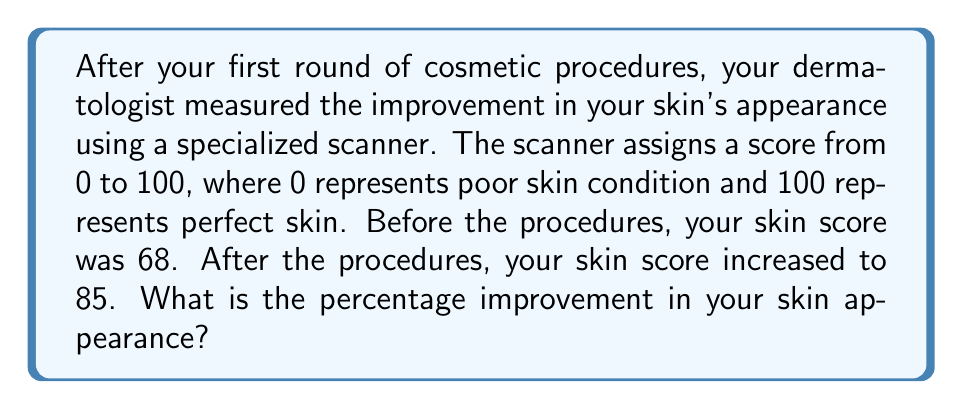Provide a solution to this math problem. To calculate the percentage improvement, we need to follow these steps:

1. Calculate the absolute improvement:
   $\text{Improvement} = \text{After score} - \text{Before score}$
   $\text{Improvement} = 85 - 68 = 17$

2. Calculate the percentage improvement:
   $$\text{Percentage Improvement} = \frac{\text{Improvement}}{\text{Before score}} \times 100\%$$
   
   $$\text{Percentage Improvement} = \frac{17}{68} \times 100\%$$

3. Simplify the fraction:
   $$\text{Percentage Improvement} = 0.25 \times 100\%$$

4. Calculate the final result:
   $$\text{Percentage Improvement} = 25\%$$

Therefore, the percentage improvement in your skin appearance is 25%.
Answer: 25% 